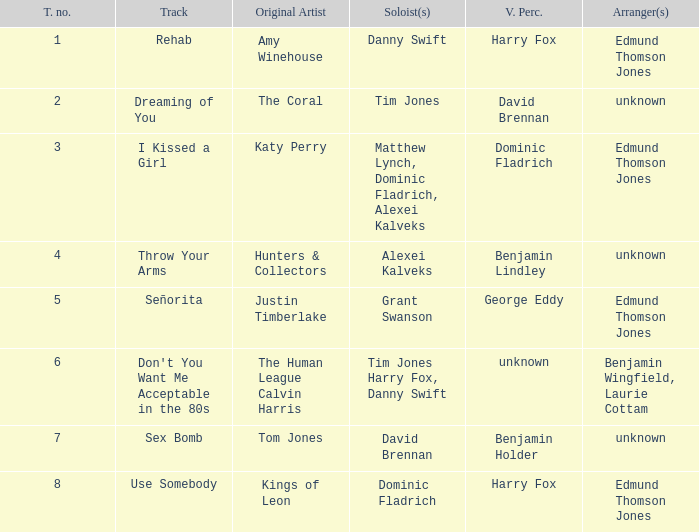Who is the arranger for "I KIssed a Girl"? Edmund Thomson Jones. 